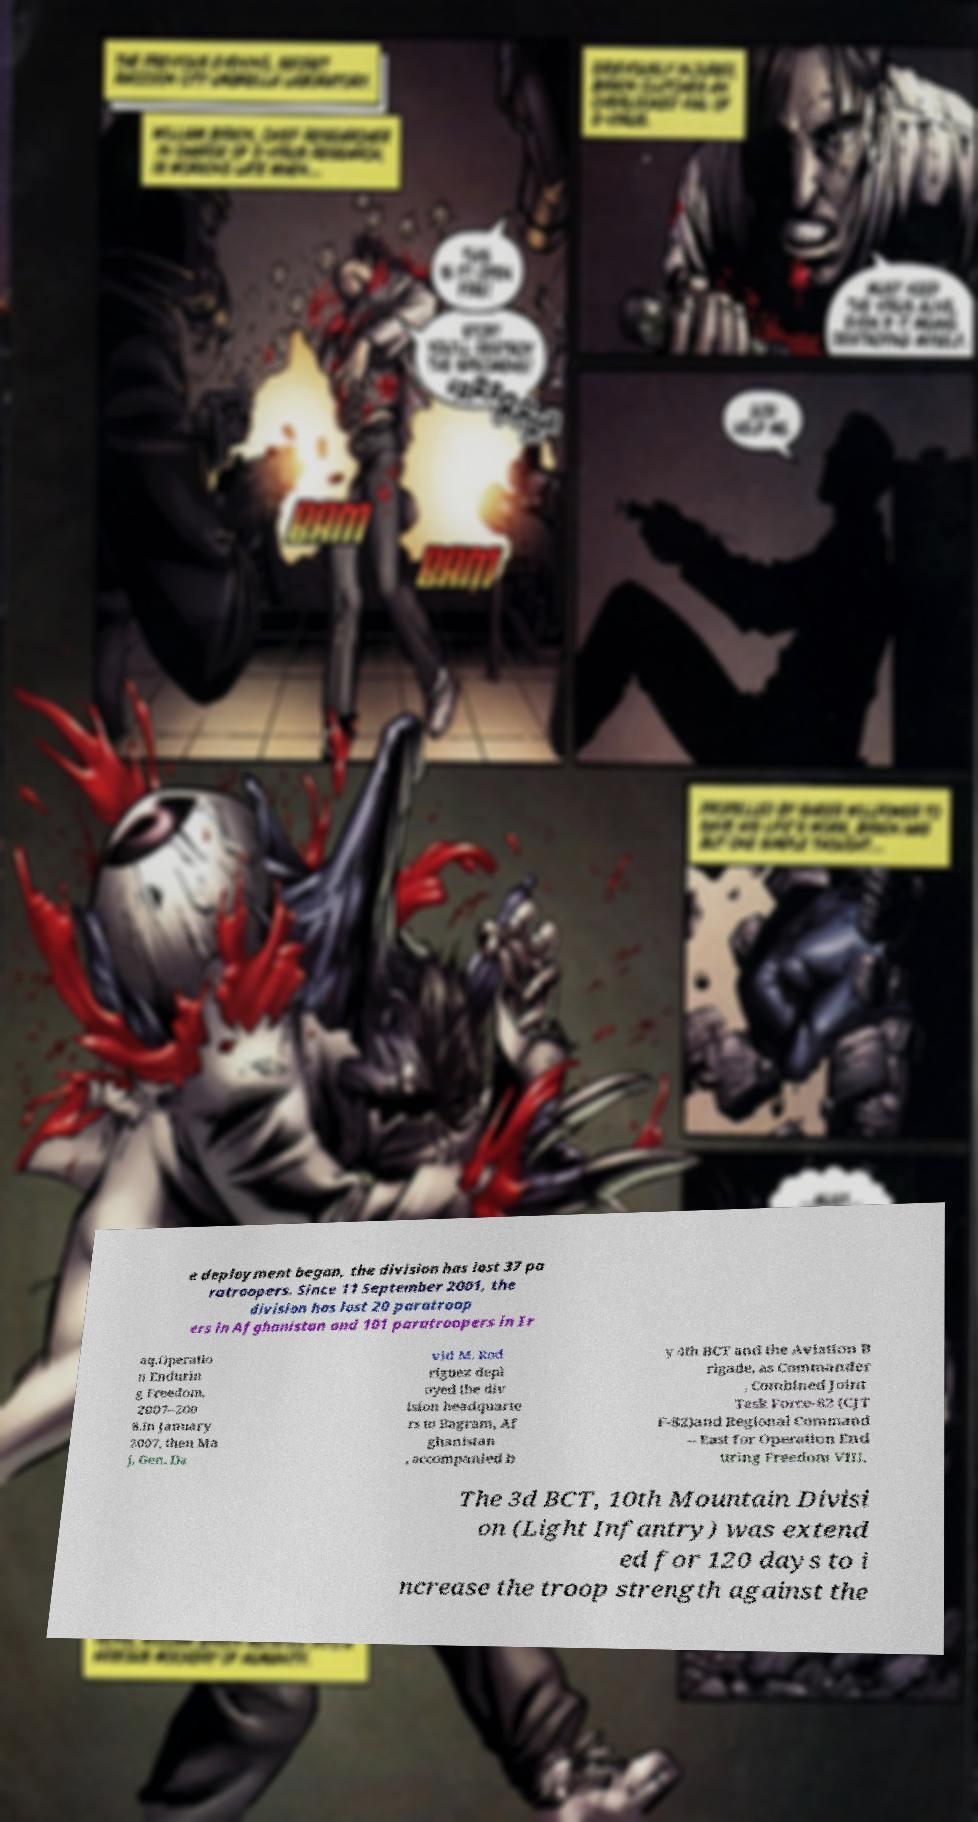What messages or text are displayed in this image? I need them in a readable, typed format. e deployment began, the division has lost 37 pa ratroopers. Since 11 September 2001, the division has lost 20 paratroop ers in Afghanistan and 101 paratroopers in Ir aq.Operatio n Endurin g Freedom, 2007–200 8.In January 2007, then Ma j. Gen. Da vid M. Rod riguez depl oyed the div ision headquarte rs to Bagram, Af ghanistan , accompanied b y 4th BCT and the Aviation B rigade, as Commander , Combined Joint Task Force-82 (CJT F-82)and Regional Command – East for Operation End uring Freedom VIII. The 3d BCT, 10th Mountain Divisi on (Light Infantry) was extend ed for 120 days to i ncrease the troop strength against the 